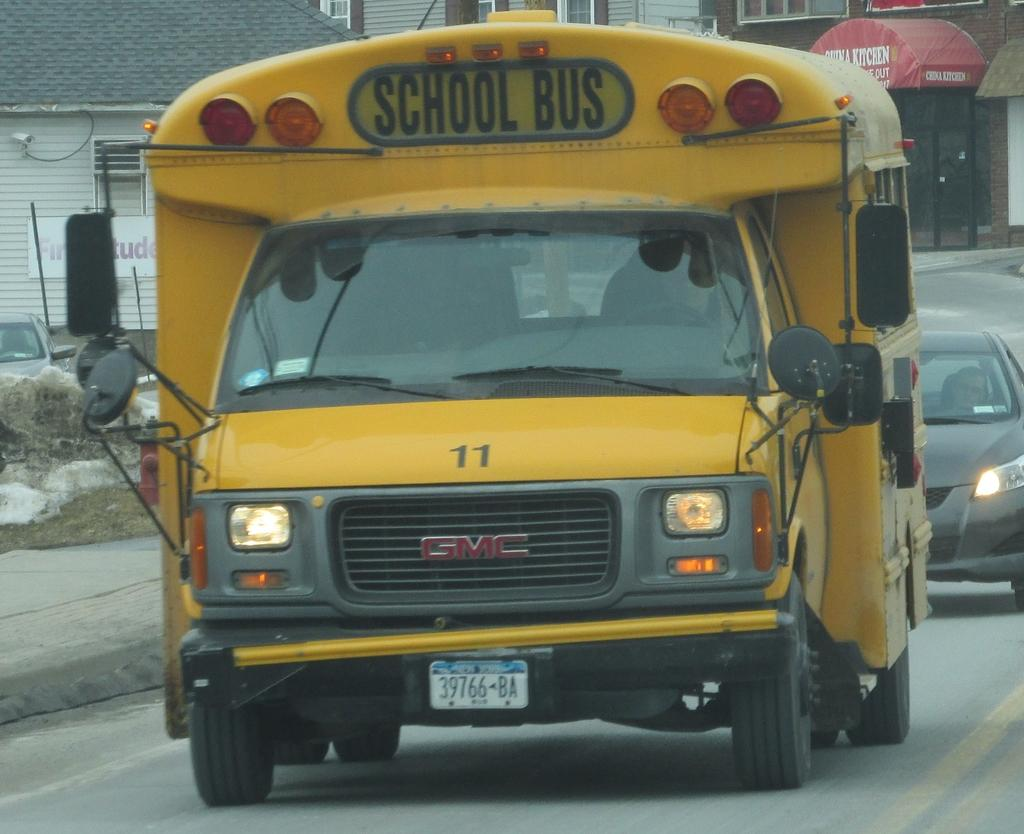What is present on the path in the image? There are vehicles on the path in the image. What can be seen on the left side of the image? There is a wall on the left side of the image. What type of vehicle can be seen in the background of the image? There is a car visible in the background of the image. What structures are visible in the background of the image? There are buildings in the background of the image. What type of hand can be seen holding a net in the image? There is no hand or net present in the image. What songs are being sung by the people in the image? There are no people or songs mentioned in the image. 